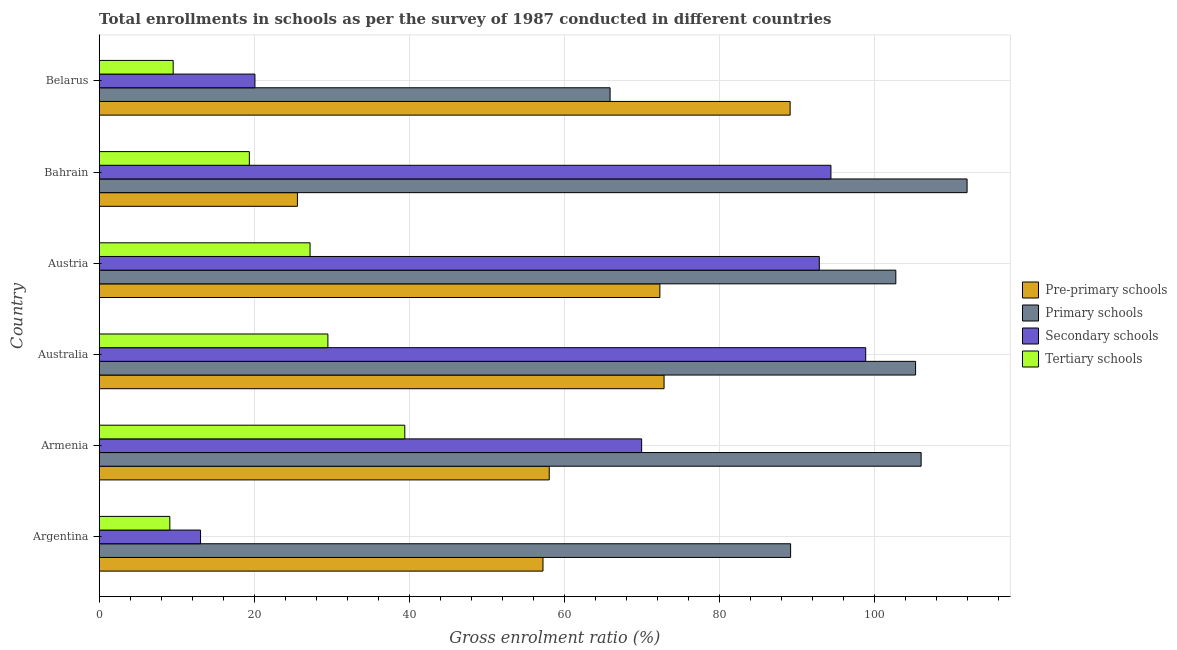How many different coloured bars are there?
Your answer should be compact. 4. Are the number of bars on each tick of the Y-axis equal?
Your response must be concise. Yes. How many bars are there on the 6th tick from the bottom?
Give a very brief answer. 4. What is the label of the 3rd group of bars from the top?
Ensure brevity in your answer.  Austria. In how many cases, is the number of bars for a given country not equal to the number of legend labels?
Provide a short and direct response. 0. What is the gross enrolment ratio in pre-primary schools in Australia?
Provide a succinct answer. 72.86. Across all countries, what is the maximum gross enrolment ratio in secondary schools?
Offer a very short reply. 98.86. Across all countries, what is the minimum gross enrolment ratio in secondary schools?
Ensure brevity in your answer.  13.07. In which country was the gross enrolment ratio in tertiary schools maximum?
Provide a succinct answer. Armenia. In which country was the gross enrolment ratio in tertiary schools minimum?
Offer a very short reply. Argentina. What is the total gross enrolment ratio in tertiary schools in the graph?
Your answer should be compact. 134.12. What is the difference between the gross enrolment ratio in secondary schools in Australia and that in Austria?
Give a very brief answer. 5.98. What is the difference between the gross enrolment ratio in tertiary schools in Australia and the gross enrolment ratio in primary schools in Armenia?
Your response must be concise. -76.52. What is the average gross enrolment ratio in pre-primary schools per country?
Your answer should be compact. 62.52. What is the difference between the gross enrolment ratio in primary schools and gross enrolment ratio in pre-primary schools in Australia?
Your response must be concise. 32.44. In how many countries, is the gross enrolment ratio in tertiary schools greater than 24 %?
Your answer should be compact. 3. What is the ratio of the gross enrolment ratio in pre-primary schools in Austria to that in Belarus?
Your answer should be very brief. 0.81. Is the gross enrolment ratio in primary schools in Armenia less than that in Austria?
Offer a terse response. No. What is the difference between the highest and the second highest gross enrolment ratio in tertiary schools?
Make the answer very short. 9.92. What is the difference between the highest and the lowest gross enrolment ratio in tertiary schools?
Your answer should be compact. 30.31. In how many countries, is the gross enrolment ratio in secondary schools greater than the average gross enrolment ratio in secondary schools taken over all countries?
Your response must be concise. 4. Is the sum of the gross enrolment ratio in secondary schools in Armenia and Australia greater than the maximum gross enrolment ratio in primary schools across all countries?
Offer a very short reply. Yes. Is it the case that in every country, the sum of the gross enrolment ratio in tertiary schools and gross enrolment ratio in secondary schools is greater than the sum of gross enrolment ratio in primary schools and gross enrolment ratio in pre-primary schools?
Give a very brief answer. No. What does the 2nd bar from the top in Argentina represents?
Offer a terse response. Secondary schools. What does the 2nd bar from the bottom in Australia represents?
Your answer should be compact. Primary schools. Is it the case that in every country, the sum of the gross enrolment ratio in pre-primary schools and gross enrolment ratio in primary schools is greater than the gross enrolment ratio in secondary schools?
Give a very brief answer. Yes. How many bars are there?
Your answer should be compact. 24. How many countries are there in the graph?
Your response must be concise. 6. What is the difference between two consecutive major ticks on the X-axis?
Make the answer very short. 20. Are the values on the major ticks of X-axis written in scientific E-notation?
Your answer should be compact. No. How are the legend labels stacked?
Your answer should be very brief. Vertical. What is the title of the graph?
Offer a very short reply. Total enrollments in schools as per the survey of 1987 conducted in different countries. Does "Secondary vocational education" appear as one of the legend labels in the graph?
Offer a terse response. No. What is the Gross enrolment ratio (%) of Pre-primary schools in Argentina?
Your answer should be very brief. 57.24. What is the Gross enrolment ratio (%) in Primary schools in Argentina?
Keep it short and to the point. 89.18. What is the Gross enrolment ratio (%) in Secondary schools in Argentina?
Give a very brief answer. 13.07. What is the Gross enrolment ratio (%) of Tertiary schools in Argentina?
Provide a succinct answer. 9.11. What is the Gross enrolment ratio (%) of Pre-primary schools in Armenia?
Offer a terse response. 58.04. What is the Gross enrolment ratio (%) in Primary schools in Armenia?
Your response must be concise. 106.01. What is the Gross enrolment ratio (%) in Secondary schools in Armenia?
Ensure brevity in your answer.  69.96. What is the Gross enrolment ratio (%) in Tertiary schools in Armenia?
Your answer should be very brief. 39.41. What is the Gross enrolment ratio (%) of Pre-primary schools in Australia?
Offer a very short reply. 72.86. What is the Gross enrolment ratio (%) in Primary schools in Australia?
Provide a succinct answer. 105.3. What is the Gross enrolment ratio (%) in Secondary schools in Australia?
Provide a short and direct response. 98.86. What is the Gross enrolment ratio (%) of Tertiary schools in Australia?
Provide a succinct answer. 29.5. What is the Gross enrolment ratio (%) of Pre-primary schools in Austria?
Offer a very short reply. 72.31. What is the Gross enrolment ratio (%) in Primary schools in Austria?
Your answer should be very brief. 102.75. What is the Gross enrolment ratio (%) in Secondary schools in Austria?
Give a very brief answer. 92.88. What is the Gross enrolment ratio (%) of Tertiary schools in Austria?
Your response must be concise. 27.19. What is the Gross enrolment ratio (%) of Pre-primary schools in Bahrain?
Offer a very short reply. 25.56. What is the Gross enrolment ratio (%) of Primary schools in Bahrain?
Your answer should be compact. 111.94. What is the Gross enrolment ratio (%) in Secondary schools in Bahrain?
Your answer should be compact. 94.38. What is the Gross enrolment ratio (%) of Tertiary schools in Bahrain?
Offer a terse response. 19.37. What is the Gross enrolment ratio (%) in Pre-primary schools in Belarus?
Make the answer very short. 89.12. What is the Gross enrolment ratio (%) in Primary schools in Belarus?
Offer a terse response. 65.89. What is the Gross enrolment ratio (%) in Secondary schools in Belarus?
Give a very brief answer. 20.09. What is the Gross enrolment ratio (%) of Tertiary schools in Belarus?
Ensure brevity in your answer.  9.54. Across all countries, what is the maximum Gross enrolment ratio (%) in Pre-primary schools?
Give a very brief answer. 89.12. Across all countries, what is the maximum Gross enrolment ratio (%) in Primary schools?
Your answer should be very brief. 111.94. Across all countries, what is the maximum Gross enrolment ratio (%) in Secondary schools?
Provide a short and direct response. 98.86. Across all countries, what is the maximum Gross enrolment ratio (%) of Tertiary schools?
Offer a very short reply. 39.41. Across all countries, what is the minimum Gross enrolment ratio (%) in Pre-primary schools?
Provide a short and direct response. 25.56. Across all countries, what is the minimum Gross enrolment ratio (%) of Primary schools?
Provide a short and direct response. 65.89. Across all countries, what is the minimum Gross enrolment ratio (%) of Secondary schools?
Keep it short and to the point. 13.07. Across all countries, what is the minimum Gross enrolment ratio (%) of Tertiary schools?
Your answer should be very brief. 9.11. What is the total Gross enrolment ratio (%) of Pre-primary schools in the graph?
Offer a very short reply. 375.13. What is the total Gross enrolment ratio (%) of Primary schools in the graph?
Your answer should be very brief. 581.07. What is the total Gross enrolment ratio (%) of Secondary schools in the graph?
Keep it short and to the point. 389.24. What is the total Gross enrolment ratio (%) of Tertiary schools in the graph?
Make the answer very short. 134.12. What is the difference between the Gross enrolment ratio (%) in Pre-primary schools in Argentina and that in Armenia?
Provide a succinct answer. -0.81. What is the difference between the Gross enrolment ratio (%) of Primary schools in Argentina and that in Armenia?
Ensure brevity in your answer.  -16.84. What is the difference between the Gross enrolment ratio (%) of Secondary schools in Argentina and that in Armenia?
Ensure brevity in your answer.  -56.89. What is the difference between the Gross enrolment ratio (%) of Tertiary schools in Argentina and that in Armenia?
Your answer should be very brief. -30.31. What is the difference between the Gross enrolment ratio (%) of Pre-primary schools in Argentina and that in Australia?
Provide a short and direct response. -15.62. What is the difference between the Gross enrolment ratio (%) in Primary schools in Argentina and that in Australia?
Provide a short and direct response. -16.12. What is the difference between the Gross enrolment ratio (%) of Secondary schools in Argentina and that in Australia?
Offer a very short reply. -85.79. What is the difference between the Gross enrolment ratio (%) of Tertiary schools in Argentina and that in Australia?
Provide a succinct answer. -20.39. What is the difference between the Gross enrolment ratio (%) of Pre-primary schools in Argentina and that in Austria?
Offer a very short reply. -15.08. What is the difference between the Gross enrolment ratio (%) in Primary schools in Argentina and that in Austria?
Offer a very short reply. -13.57. What is the difference between the Gross enrolment ratio (%) in Secondary schools in Argentina and that in Austria?
Offer a terse response. -79.81. What is the difference between the Gross enrolment ratio (%) of Tertiary schools in Argentina and that in Austria?
Your answer should be very brief. -18.09. What is the difference between the Gross enrolment ratio (%) in Pre-primary schools in Argentina and that in Bahrain?
Ensure brevity in your answer.  31.67. What is the difference between the Gross enrolment ratio (%) in Primary schools in Argentina and that in Bahrain?
Your answer should be very brief. -22.76. What is the difference between the Gross enrolment ratio (%) in Secondary schools in Argentina and that in Bahrain?
Provide a succinct answer. -81.31. What is the difference between the Gross enrolment ratio (%) of Tertiary schools in Argentina and that in Bahrain?
Offer a very short reply. -10.26. What is the difference between the Gross enrolment ratio (%) of Pre-primary schools in Argentina and that in Belarus?
Ensure brevity in your answer.  -31.88. What is the difference between the Gross enrolment ratio (%) in Primary schools in Argentina and that in Belarus?
Keep it short and to the point. 23.28. What is the difference between the Gross enrolment ratio (%) of Secondary schools in Argentina and that in Belarus?
Give a very brief answer. -7.02. What is the difference between the Gross enrolment ratio (%) of Tertiary schools in Argentina and that in Belarus?
Ensure brevity in your answer.  -0.43. What is the difference between the Gross enrolment ratio (%) of Pre-primary schools in Armenia and that in Australia?
Provide a short and direct response. -14.81. What is the difference between the Gross enrolment ratio (%) in Primary schools in Armenia and that in Australia?
Offer a terse response. 0.72. What is the difference between the Gross enrolment ratio (%) in Secondary schools in Armenia and that in Australia?
Give a very brief answer. -28.9. What is the difference between the Gross enrolment ratio (%) of Tertiary schools in Armenia and that in Australia?
Make the answer very short. 9.92. What is the difference between the Gross enrolment ratio (%) of Pre-primary schools in Armenia and that in Austria?
Ensure brevity in your answer.  -14.27. What is the difference between the Gross enrolment ratio (%) in Primary schools in Armenia and that in Austria?
Offer a very short reply. 3.26. What is the difference between the Gross enrolment ratio (%) of Secondary schools in Armenia and that in Austria?
Ensure brevity in your answer.  -22.92. What is the difference between the Gross enrolment ratio (%) of Tertiary schools in Armenia and that in Austria?
Give a very brief answer. 12.22. What is the difference between the Gross enrolment ratio (%) of Pre-primary schools in Armenia and that in Bahrain?
Give a very brief answer. 32.48. What is the difference between the Gross enrolment ratio (%) in Primary schools in Armenia and that in Bahrain?
Provide a succinct answer. -5.93. What is the difference between the Gross enrolment ratio (%) of Secondary schools in Armenia and that in Bahrain?
Your answer should be compact. -24.42. What is the difference between the Gross enrolment ratio (%) of Tertiary schools in Armenia and that in Bahrain?
Ensure brevity in your answer.  20.05. What is the difference between the Gross enrolment ratio (%) of Pre-primary schools in Armenia and that in Belarus?
Keep it short and to the point. -31.07. What is the difference between the Gross enrolment ratio (%) of Primary schools in Armenia and that in Belarus?
Provide a short and direct response. 40.12. What is the difference between the Gross enrolment ratio (%) of Secondary schools in Armenia and that in Belarus?
Make the answer very short. 49.88. What is the difference between the Gross enrolment ratio (%) of Tertiary schools in Armenia and that in Belarus?
Give a very brief answer. 29.87. What is the difference between the Gross enrolment ratio (%) of Pre-primary schools in Australia and that in Austria?
Ensure brevity in your answer.  0.54. What is the difference between the Gross enrolment ratio (%) in Primary schools in Australia and that in Austria?
Ensure brevity in your answer.  2.55. What is the difference between the Gross enrolment ratio (%) of Secondary schools in Australia and that in Austria?
Keep it short and to the point. 5.98. What is the difference between the Gross enrolment ratio (%) of Tertiary schools in Australia and that in Austria?
Make the answer very short. 2.3. What is the difference between the Gross enrolment ratio (%) of Pre-primary schools in Australia and that in Bahrain?
Your response must be concise. 47.29. What is the difference between the Gross enrolment ratio (%) in Primary schools in Australia and that in Bahrain?
Provide a succinct answer. -6.64. What is the difference between the Gross enrolment ratio (%) of Secondary schools in Australia and that in Bahrain?
Ensure brevity in your answer.  4.48. What is the difference between the Gross enrolment ratio (%) in Tertiary schools in Australia and that in Bahrain?
Ensure brevity in your answer.  10.13. What is the difference between the Gross enrolment ratio (%) of Pre-primary schools in Australia and that in Belarus?
Make the answer very short. -16.26. What is the difference between the Gross enrolment ratio (%) of Primary schools in Australia and that in Belarus?
Offer a terse response. 39.4. What is the difference between the Gross enrolment ratio (%) in Secondary schools in Australia and that in Belarus?
Make the answer very short. 78.78. What is the difference between the Gross enrolment ratio (%) in Tertiary schools in Australia and that in Belarus?
Your answer should be very brief. 19.95. What is the difference between the Gross enrolment ratio (%) of Pre-primary schools in Austria and that in Bahrain?
Give a very brief answer. 46.75. What is the difference between the Gross enrolment ratio (%) in Primary schools in Austria and that in Bahrain?
Give a very brief answer. -9.19. What is the difference between the Gross enrolment ratio (%) of Secondary schools in Austria and that in Bahrain?
Keep it short and to the point. -1.5. What is the difference between the Gross enrolment ratio (%) in Tertiary schools in Austria and that in Bahrain?
Your answer should be compact. 7.83. What is the difference between the Gross enrolment ratio (%) of Pre-primary schools in Austria and that in Belarus?
Give a very brief answer. -16.8. What is the difference between the Gross enrolment ratio (%) of Primary schools in Austria and that in Belarus?
Ensure brevity in your answer.  36.86. What is the difference between the Gross enrolment ratio (%) of Secondary schools in Austria and that in Belarus?
Ensure brevity in your answer.  72.79. What is the difference between the Gross enrolment ratio (%) of Tertiary schools in Austria and that in Belarus?
Your answer should be very brief. 17.65. What is the difference between the Gross enrolment ratio (%) of Pre-primary schools in Bahrain and that in Belarus?
Provide a succinct answer. -63.55. What is the difference between the Gross enrolment ratio (%) in Primary schools in Bahrain and that in Belarus?
Your answer should be compact. 46.05. What is the difference between the Gross enrolment ratio (%) in Secondary schools in Bahrain and that in Belarus?
Keep it short and to the point. 74.29. What is the difference between the Gross enrolment ratio (%) of Tertiary schools in Bahrain and that in Belarus?
Your answer should be compact. 9.83. What is the difference between the Gross enrolment ratio (%) of Pre-primary schools in Argentina and the Gross enrolment ratio (%) of Primary schools in Armenia?
Make the answer very short. -48.78. What is the difference between the Gross enrolment ratio (%) in Pre-primary schools in Argentina and the Gross enrolment ratio (%) in Secondary schools in Armenia?
Ensure brevity in your answer.  -12.73. What is the difference between the Gross enrolment ratio (%) in Pre-primary schools in Argentina and the Gross enrolment ratio (%) in Tertiary schools in Armenia?
Offer a very short reply. 17.82. What is the difference between the Gross enrolment ratio (%) in Primary schools in Argentina and the Gross enrolment ratio (%) in Secondary schools in Armenia?
Offer a very short reply. 19.22. What is the difference between the Gross enrolment ratio (%) of Primary schools in Argentina and the Gross enrolment ratio (%) of Tertiary schools in Armenia?
Make the answer very short. 49.76. What is the difference between the Gross enrolment ratio (%) of Secondary schools in Argentina and the Gross enrolment ratio (%) of Tertiary schools in Armenia?
Your answer should be very brief. -26.35. What is the difference between the Gross enrolment ratio (%) of Pre-primary schools in Argentina and the Gross enrolment ratio (%) of Primary schools in Australia?
Give a very brief answer. -48.06. What is the difference between the Gross enrolment ratio (%) in Pre-primary schools in Argentina and the Gross enrolment ratio (%) in Secondary schools in Australia?
Your response must be concise. -41.63. What is the difference between the Gross enrolment ratio (%) of Pre-primary schools in Argentina and the Gross enrolment ratio (%) of Tertiary schools in Australia?
Your response must be concise. 27.74. What is the difference between the Gross enrolment ratio (%) in Primary schools in Argentina and the Gross enrolment ratio (%) in Secondary schools in Australia?
Ensure brevity in your answer.  -9.68. What is the difference between the Gross enrolment ratio (%) in Primary schools in Argentina and the Gross enrolment ratio (%) in Tertiary schools in Australia?
Offer a terse response. 59.68. What is the difference between the Gross enrolment ratio (%) of Secondary schools in Argentina and the Gross enrolment ratio (%) of Tertiary schools in Australia?
Your answer should be very brief. -16.43. What is the difference between the Gross enrolment ratio (%) in Pre-primary schools in Argentina and the Gross enrolment ratio (%) in Primary schools in Austria?
Your answer should be very brief. -45.51. What is the difference between the Gross enrolment ratio (%) in Pre-primary schools in Argentina and the Gross enrolment ratio (%) in Secondary schools in Austria?
Make the answer very short. -35.64. What is the difference between the Gross enrolment ratio (%) in Pre-primary schools in Argentina and the Gross enrolment ratio (%) in Tertiary schools in Austria?
Keep it short and to the point. 30.04. What is the difference between the Gross enrolment ratio (%) in Primary schools in Argentina and the Gross enrolment ratio (%) in Secondary schools in Austria?
Give a very brief answer. -3.7. What is the difference between the Gross enrolment ratio (%) in Primary schools in Argentina and the Gross enrolment ratio (%) in Tertiary schools in Austria?
Your answer should be very brief. 61.98. What is the difference between the Gross enrolment ratio (%) in Secondary schools in Argentina and the Gross enrolment ratio (%) in Tertiary schools in Austria?
Keep it short and to the point. -14.13. What is the difference between the Gross enrolment ratio (%) of Pre-primary schools in Argentina and the Gross enrolment ratio (%) of Primary schools in Bahrain?
Offer a very short reply. -54.7. What is the difference between the Gross enrolment ratio (%) in Pre-primary schools in Argentina and the Gross enrolment ratio (%) in Secondary schools in Bahrain?
Give a very brief answer. -37.14. What is the difference between the Gross enrolment ratio (%) of Pre-primary schools in Argentina and the Gross enrolment ratio (%) of Tertiary schools in Bahrain?
Provide a short and direct response. 37.87. What is the difference between the Gross enrolment ratio (%) of Primary schools in Argentina and the Gross enrolment ratio (%) of Tertiary schools in Bahrain?
Make the answer very short. 69.81. What is the difference between the Gross enrolment ratio (%) in Secondary schools in Argentina and the Gross enrolment ratio (%) in Tertiary schools in Bahrain?
Your response must be concise. -6.3. What is the difference between the Gross enrolment ratio (%) in Pre-primary schools in Argentina and the Gross enrolment ratio (%) in Primary schools in Belarus?
Give a very brief answer. -8.66. What is the difference between the Gross enrolment ratio (%) of Pre-primary schools in Argentina and the Gross enrolment ratio (%) of Secondary schools in Belarus?
Make the answer very short. 37.15. What is the difference between the Gross enrolment ratio (%) of Pre-primary schools in Argentina and the Gross enrolment ratio (%) of Tertiary schools in Belarus?
Keep it short and to the point. 47.7. What is the difference between the Gross enrolment ratio (%) in Primary schools in Argentina and the Gross enrolment ratio (%) in Secondary schools in Belarus?
Your answer should be compact. 69.09. What is the difference between the Gross enrolment ratio (%) of Primary schools in Argentina and the Gross enrolment ratio (%) of Tertiary schools in Belarus?
Give a very brief answer. 79.64. What is the difference between the Gross enrolment ratio (%) of Secondary schools in Argentina and the Gross enrolment ratio (%) of Tertiary schools in Belarus?
Offer a terse response. 3.53. What is the difference between the Gross enrolment ratio (%) in Pre-primary schools in Armenia and the Gross enrolment ratio (%) in Primary schools in Australia?
Provide a succinct answer. -47.25. What is the difference between the Gross enrolment ratio (%) of Pre-primary schools in Armenia and the Gross enrolment ratio (%) of Secondary schools in Australia?
Offer a very short reply. -40.82. What is the difference between the Gross enrolment ratio (%) in Pre-primary schools in Armenia and the Gross enrolment ratio (%) in Tertiary schools in Australia?
Give a very brief answer. 28.55. What is the difference between the Gross enrolment ratio (%) of Primary schools in Armenia and the Gross enrolment ratio (%) of Secondary schools in Australia?
Give a very brief answer. 7.15. What is the difference between the Gross enrolment ratio (%) of Primary schools in Armenia and the Gross enrolment ratio (%) of Tertiary schools in Australia?
Offer a very short reply. 76.52. What is the difference between the Gross enrolment ratio (%) of Secondary schools in Armenia and the Gross enrolment ratio (%) of Tertiary schools in Australia?
Make the answer very short. 40.47. What is the difference between the Gross enrolment ratio (%) in Pre-primary schools in Armenia and the Gross enrolment ratio (%) in Primary schools in Austria?
Provide a short and direct response. -44.71. What is the difference between the Gross enrolment ratio (%) in Pre-primary schools in Armenia and the Gross enrolment ratio (%) in Secondary schools in Austria?
Ensure brevity in your answer.  -34.84. What is the difference between the Gross enrolment ratio (%) in Pre-primary schools in Armenia and the Gross enrolment ratio (%) in Tertiary schools in Austria?
Provide a short and direct response. 30.85. What is the difference between the Gross enrolment ratio (%) in Primary schools in Armenia and the Gross enrolment ratio (%) in Secondary schools in Austria?
Provide a short and direct response. 13.13. What is the difference between the Gross enrolment ratio (%) in Primary schools in Armenia and the Gross enrolment ratio (%) in Tertiary schools in Austria?
Offer a terse response. 78.82. What is the difference between the Gross enrolment ratio (%) of Secondary schools in Armenia and the Gross enrolment ratio (%) of Tertiary schools in Austria?
Ensure brevity in your answer.  42.77. What is the difference between the Gross enrolment ratio (%) of Pre-primary schools in Armenia and the Gross enrolment ratio (%) of Primary schools in Bahrain?
Provide a short and direct response. -53.9. What is the difference between the Gross enrolment ratio (%) in Pre-primary schools in Armenia and the Gross enrolment ratio (%) in Secondary schools in Bahrain?
Offer a very short reply. -36.33. What is the difference between the Gross enrolment ratio (%) of Pre-primary schools in Armenia and the Gross enrolment ratio (%) of Tertiary schools in Bahrain?
Your response must be concise. 38.68. What is the difference between the Gross enrolment ratio (%) in Primary schools in Armenia and the Gross enrolment ratio (%) in Secondary schools in Bahrain?
Make the answer very short. 11.64. What is the difference between the Gross enrolment ratio (%) of Primary schools in Armenia and the Gross enrolment ratio (%) of Tertiary schools in Bahrain?
Keep it short and to the point. 86.65. What is the difference between the Gross enrolment ratio (%) of Secondary schools in Armenia and the Gross enrolment ratio (%) of Tertiary schools in Bahrain?
Provide a succinct answer. 50.6. What is the difference between the Gross enrolment ratio (%) of Pre-primary schools in Armenia and the Gross enrolment ratio (%) of Primary schools in Belarus?
Ensure brevity in your answer.  -7.85. What is the difference between the Gross enrolment ratio (%) of Pre-primary schools in Armenia and the Gross enrolment ratio (%) of Secondary schools in Belarus?
Offer a very short reply. 37.96. What is the difference between the Gross enrolment ratio (%) of Pre-primary schools in Armenia and the Gross enrolment ratio (%) of Tertiary schools in Belarus?
Make the answer very short. 48.5. What is the difference between the Gross enrolment ratio (%) in Primary schools in Armenia and the Gross enrolment ratio (%) in Secondary schools in Belarus?
Offer a very short reply. 85.93. What is the difference between the Gross enrolment ratio (%) of Primary schools in Armenia and the Gross enrolment ratio (%) of Tertiary schools in Belarus?
Your answer should be very brief. 96.47. What is the difference between the Gross enrolment ratio (%) of Secondary schools in Armenia and the Gross enrolment ratio (%) of Tertiary schools in Belarus?
Your answer should be compact. 60.42. What is the difference between the Gross enrolment ratio (%) in Pre-primary schools in Australia and the Gross enrolment ratio (%) in Primary schools in Austria?
Provide a short and direct response. -29.89. What is the difference between the Gross enrolment ratio (%) in Pre-primary schools in Australia and the Gross enrolment ratio (%) in Secondary schools in Austria?
Make the answer very short. -20.02. What is the difference between the Gross enrolment ratio (%) in Pre-primary schools in Australia and the Gross enrolment ratio (%) in Tertiary schools in Austria?
Provide a short and direct response. 45.66. What is the difference between the Gross enrolment ratio (%) in Primary schools in Australia and the Gross enrolment ratio (%) in Secondary schools in Austria?
Make the answer very short. 12.42. What is the difference between the Gross enrolment ratio (%) of Primary schools in Australia and the Gross enrolment ratio (%) of Tertiary schools in Austria?
Keep it short and to the point. 78.1. What is the difference between the Gross enrolment ratio (%) in Secondary schools in Australia and the Gross enrolment ratio (%) in Tertiary schools in Austria?
Ensure brevity in your answer.  71.67. What is the difference between the Gross enrolment ratio (%) of Pre-primary schools in Australia and the Gross enrolment ratio (%) of Primary schools in Bahrain?
Make the answer very short. -39.08. What is the difference between the Gross enrolment ratio (%) in Pre-primary schools in Australia and the Gross enrolment ratio (%) in Secondary schools in Bahrain?
Offer a terse response. -21.52. What is the difference between the Gross enrolment ratio (%) in Pre-primary schools in Australia and the Gross enrolment ratio (%) in Tertiary schools in Bahrain?
Your answer should be very brief. 53.49. What is the difference between the Gross enrolment ratio (%) of Primary schools in Australia and the Gross enrolment ratio (%) of Secondary schools in Bahrain?
Your answer should be compact. 10.92. What is the difference between the Gross enrolment ratio (%) in Primary schools in Australia and the Gross enrolment ratio (%) in Tertiary schools in Bahrain?
Your answer should be compact. 85.93. What is the difference between the Gross enrolment ratio (%) of Secondary schools in Australia and the Gross enrolment ratio (%) of Tertiary schools in Bahrain?
Your answer should be very brief. 79.5. What is the difference between the Gross enrolment ratio (%) in Pre-primary schools in Australia and the Gross enrolment ratio (%) in Primary schools in Belarus?
Give a very brief answer. 6.96. What is the difference between the Gross enrolment ratio (%) in Pre-primary schools in Australia and the Gross enrolment ratio (%) in Secondary schools in Belarus?
Ensure brevity in your answer.  52.77. What is the difference between the Gross enrolment ratio (%) of Pre-primary schools in Australia and the Gross enrolment ratio (%) of Tertiary schools in Belarus?
Offer a terse response. 63.32. What is the difference between the Gross enrolment ratio (%) of Primary schools in Australia and the Gross enrolment ratio (%) of Secondary schools in Belarus?
Ensure brevity in your answer.  85.21. What is the difference between the Gross enrolment ratio (%) in Primary schools in Australia and the Gross enrolment ratio (%) in Tertiary schools in Belarus?
Provide a succinct answer. 95.76. What is the difference between the Gross enrolment ratio (%) in Secondary schools in Australia and the Gross enrolment ratio (%) in Tertiary schools in Belarus?
Offer a terse response. 89.32. What is the difference between the Gross enrolment ratio (%) of Pre-primary schools in Austria and the Gross enrolment ratio (%) of Primary schools in Bahrain?
Your response must be concise. -39.62. What is the difference between the Gross enrolment ratio (%) in Pre-primary schools in Austria and the Gross enrolment ratio (%) in Secondary schools in Bahrain?
Your response must be concise. -22.06. What is the difference between the Gross enrolment ratio (%) of Pre-primary schools in Austria and the Gross enrolment ratio (%) of Tertiary schools in Bahrain?
Offer a terse response. 52.95. What is the difference between the Gross enrolment ratio (%) in Primary schools in Austria and the Gross enrolment ratio (%) in Secondary schools in Bahrain?
Your answer should be compact. 8.37. What is the difference between the Gross enrolment ratio (%) in Primary schools in Austria and the Gross enrolment ratio (%) in Tertiary schools in Bahrain?
Keep it short and to the point. 83.38. What is the difference between the Gross enrolment ratio (%) of Secondary schools in Austria and the Gross enrolment ratio (%) of Tertiary schools in Bahrain?
Offer a very short reply. 73.51. What is the difference between the Gross enrolment ratio (%) of Pre-primary schools in Austria and the Gross enrolment ratio (%) of Primary schools in Belarus?
Ensure brevity in your answer.  6.42. What is the difference between the Gross enrolment ratio (%) of Pre-primary schools in Austria and the Gross enrolment ratio (%) of Secondary schools in Belarus?
Ensure brevity in your answer.  52.23. What is the difference between the Gross enrolment ratio (%) of Pre-primary schools in Austria and the Gross enrolment ratio (%) of Tertiary schools in Belarus?
Your answer should be very brief. 62.77. What is the difference between the Gross enrolment ratio (%) of Primary schools in Austria and the Gross enrolment ratio (%) of Secondary schools in Belarus?
Make the answer very short. 82.66. What is the difference between the Gross enrolment ratio (%) of Primary schools in Austria and the Gross enrolment ratio (%) of Tertiary schools in Belarus?
Offer a terse response. 93.21. What is the difference between the Gross enrolment ratio (%) of Secondary schools in Austria and the Gross enrolment ratio (%) of Tertiary schools in Belarus?
Keep it short and to the point. 83.34. What is the difference between the Gross enrolment ratio (%) of Pre-primary schools in Bahrain and the Gross enrolment ratio (%) of Primary schools in Belarus?
Offer a very short reply. -40.33. What is the difference between the Gross enrolment ratio (%) in Pre-primary schools in Bahrain and the Gross enrolment ratio (%) in Secondary schools in Belarus?
Your response must be concise. 5.48. What is the difference between the Gross enrolment ratio (%) of Pre-primary schools in Bahrain and the Gross enrolment ratio (%) of Tertiary schools in Belarus?
Your response must be concise. 16.02. What is the difference between the Gross enrolment ratio (%) of Primary schools in Bahrain and the Gross enrolment ratio (%) of Secondary schools in Belarus?
Give a very brief answer. 91.85. What is the difference between the Gross enrolment ratio (%) of Primary schools in Bahrain and the Gross enrolment ratio (%) of Tertiary schools in Belarus?
Give a very brief answer. 102.4. What is the difference between the Gross enrolment ratio (%) in Secondary schools in Bahrain and the Gross enrolment ratio (%) in Tertiary schools in Belarus?
Ensure brevity in your answer.  84.84. What is the average Gross enrolment ratio (%) in Pre-primary schools per country?
Provide a short and direct response. 62.52. What is the average Gross enrolment ratio (%) of Primary schools per country?
Give a very brief answer. 96.84. What is the average Gross enrolment ratio (%) in Secondary schools per country?
Provide a succinct answer. 64.87. What is the average Gross enrolment ratio (%) of Tertiary schools per country?
Give a very brief answer. 22.35. What is the difference between the Gross enrolment ratio (%) of Pre-primary schools and Gross enrolment ratio (%) of Primary schools in Argentina?
Ensure brevity in your answer.  -31.94. What is the difference between the Gross enrolment ratio (%) in Pre-primary schools and Gross enrolment ratio (%) in Secondary schools in Argentina?
Keep it short and to the point. 44.17. What is the difference between the Gross enrolment ratio (%) of Pre-primary schools and Gross enrolment ratio (%) of Tertiary schools in Argentina?
Your answer should be very brief. 48.13. What is the difference between the Gross enrolment ratio (%) of Primary schools and Gross enrolment ratio (%) of Secondary schools in Argentina?
Make the answer very short. 76.11. What is the difference between the Gross enrolment ratio (%) in Primary schools and Gross enrolment ratio (%) in Tertiary schools in Argentina?
Your answer should be very brief. 80.07. What is the difference between the Gross enrolment ratio (%) of Secondary schools and Gross enrolment ratio (%) of Tertiary schools in Argentina?
Give a very brief answer. 3.96. What is the difference between the Gross enrolment ratio (%) of Pre-primary schools and Gross enrolment ratio (%) of Primary schools in Armenia?
Provide a short and direct response. -47.97. What is the difference between the Gross enrolment ratio (%) in Pre-primary schools and Gross enrolment ratio (%) in Secondary schools in Armenia?
Make the answer very short. -11.92. What is the difference between the Gross enrolment ratio (%) of Pre-primary schools and Gross enrolment ratio (%) of Tertiary schools in Armenia?
Your answer should be very brief. 18.63. What is the difference between the Gross enrolment ratio (%) in Primary schools and Gross enrolment ratio (%) in Secondary schools in Armenia?
Provide a short and direct response. 36.05. What is the difference between the Gross enrolment ratio (%) in Primary schools and Gross enrolment ratio (%) in Tertiary schools in Armenia?
Provide a succinct answer. 66.6. What is the difference between the Gross enrolment ratio (%) of Secondary schools and Gross enrolment ratio (%) of Tertiary schools in Armenia?
Give a very brief answer. 30.55. What is the difference between the Gross enrolment ratio (%) in Pre-primary schools and Gross enrolment ratio (%) in Primary schools in Australia?
Your response must be concise. -32.44. What is the difference between the Gross enrolment ratio (%) of Pre-primary schools and Gross enrolment ratio (%) of Secondary schools in Australia?
Keep it short and to the point. -26.01. What is the difference between the Gross enrolment ratio (%) in Pre-primary schools and Gross enrolment ratio (%) in Tertiary schools in Australia?
Offer a terse response. 43.36. What is the difference between the Gross enrolment ratio (%) of Primary schools and Gross enrolment ratio (%) of Secondary schools in Australia?
Make the answer very short. 6.44. What is the difference between the Gross enrolment ratio (%) of Primary schools and Gross enrolment ratio (%) of Tertiary schools in Australia?
Ensure brevity in your answer.  75.8. What is the difference between the Gross enrolment ratio (%) of Secondary schools and Gross enrolment ratio (%) of Tertiary schools in Australia?
Offer a very short reply. 69.37. What is the difference between the Gross enrolment ratio (%) in Pre-primary schools and Gross enrolment ratio (%) in Primary schools in Austria?
Your answer should be very brief. -30.43. What is the difference between the Gross enrolment ratio (%) of Pre-primary schools and Gross enrolment ratio (%) of Secondary schools in Austria?
Your answer should be very brief. -20.57. What is the difference between the Gross enrolment ratio (%) in Pre-primary schools and Gross enrolment ratio (%) in Tertiary schools in Austria?
Provide a short and direct response. 45.12. What is the difference between the Gross enrolment ratio (%) in Primary schools and Gross enrolment ratio (%) in Secondary schools in Austria?
Give a very brief answer. 9.87. What is the difference between the Gross enrolment ratio (%) of Primary schools and Gross enrolment ratio (%) of Tertiary schools in Austria?
Ensure brevity in your answer.  75.55. What is the difference between the Gross enrolment ratio (%) in Secondary schools and Gross enrolment ratio (%) in Tertiary schools in Austria?
Offer a terse response. 65.68. What is the difference between the Gross enrolment ratio (%) in Pre-primary schools and Gross enrolment ratio (%) in Primary schools in Bahrain?
Offer a very short reply. -86.37. What is the difference between the Gross enrolment ratio (%) of Pre-primary schools and Gross enrolment ratio (%) of Secondary schools in Bahrain?
Provide a short and direct response. -68.81. What is the difference between the Gross enrolment ratio (%) of Pre-primary schools and Gross enrolment ratio (%) of Tertiary schools in Bahrain?
Offer a terse response. 6.2. What is the difference between the Gross enrolment ratio (%) of Primary schools and Gross enrolment ratio (%) of Secondary schools in Bahrain?
Your answer should be very brief. 17.56. What is the difference between the Gross enrolment ratio (%) of Primary schools and Gross enrolment ratio (%) of Tertiary schools in Bahrain?
Provide a succinct answer. 92.57. What is the difference between the Gross enrolment ratio (%) of Secondary schools and Gross enrolment ratio (%) of Tertiary schools in Bahrain?
Your answer should be very brief. 75.01. What is the difference between the Gross enrolment ratio (%) of Pre-primary schools and Gross enrolment ratio (%) of Primary schools in Belarus?
Keep it short and to the point. 23.22. What is the difference between the Gross enrolment ratio (%) of Pre-primary schools and Gross enrolment ratio (%) of Secondary schools in Belarus?
Give a very brief answer. 69.03. What is the difference between the Gross enrolment ratio (%) in Pre-primary schools and Gross enrolment ratio (%) in Tertiary schools in Belarus?
Your response must be concise. 79.58. What is the difference between the Gross enrolment ratio (%) of Primary schools and Gross enrolment ratio (%) of Secondary schools in Belarus?
Your answer should be compact. 45.81. What is the difference between the Gross enrolment ratio (%) of Primary schools and Gross enrolment ratio (%) of Tertiary schools in Belarus?
Your answer should be very brief. 56.35. What is the difference between the Gross enrolment ratio (%) of Secondary schools and Gross enrolment ratio (%) of Tertiary schools in Belarus?
Make the answer very short. 10.55. What is the ratio of the Gross enrolment ratio (%) of Pre-primary schools in Argentina to that in Armenia?
Ensure brevity in your answer.  0.99. What is the ratio of the Gross enrolment ratio (%) in Primary schools in Argentina to that in Armenia?
Keep it short and to the point. 0.84. What is the ratio of the Gross enrolment ratio (%) in Secondary schools in Argentina to that in Armenia?
Offer a terse response. 0.19. What is the ratio of the Gross enrolment ratio (%) of Tertiary schools in Argentina to that in Armenia?
Your response must be concise. 0.23. What is the ratio of the Gross enrolment ratio (%) of Pre-primary schools in Argentina to that in Australia?
Your response must be concise. 0.79. What is the ratio of the Gross enrolment ratio (%) of Primary schools in Argentina to that in Australia?
Provide a succinct answer. 0.85. What is the ratio of the Gross enrolment ratio (%) of Secondary schools in Argentina to that in Australia?
Give a very brief answer. 0.13. What is the ratio of the Gross enrolment ratio (%) of Tertiary schools in Argentina to that in Australia?
Keep it short and to the point. 0.31. What is the ratio of the Gross enrolment ratio (%) of Pre-primary schools in Argentina to that in Austria?
Keep it short and to the point. 0.79. What is the ratio of the Gross enrolment ratio (%) of Primary schools in Argentina to that in Austria?
Give a very brief answer. 0.87. What is the ratio of the Gross enrolment ratio (%) of Secondary schools in Argentina to that in Austria?
Provide a succinct answer. 0.14. What is the ratio of the Gross enrolment ratio (%) of Tertiary schools in Argentina to that in Austria?
Provide a short and direct response. 0.33. What is the ratio of the Gross enrolment ratio (%) in Pre-primary schools in Argentina to that in Bahrain?
Offer a terse response. 2.24. What is the ratio of the Gross enrolment ratio (%) of Primary schools in Argentina to that in Bahrain?
Your answer should be compact. 0.8. What is the ratio of the Gross enrolment ratio (%) in Secondary schools in Argentina to that in Bahrain?
Offer a very short reply. 0.14. What is the ratio of the Gross enrolment ratio (%) of Tertiary schools in Argentina to that in Bahrain?
Your answer should be compact. 0.47. What is the ratio of the Gross enrolment ratio (%) of Pre-primary schools in Argentina to that in Belarus?
Give a very brief answer. 0.64. What is the ratio of the Gross enrolment ratio (%) of Primary schools in Argentina to that in Belarus?
Give a very brief answer. 1.35. What is the ratio of the Gross enrolment ratio (%) of Secondary schools in Argentina to that in Belarus?
Make the answer very short. 0.65. What is the ratio of the Gross enrolment ratio (%) of Tertiary schools in Argentina to that in Belarus?
Your answer should be compact. 0.95. What is the ratio of the Gross enrolment ratio (%) of Pre-primary schools in Armenia to that in Australia?
Provide a succinct answer. 0.8. What is the ratio of the Gross enrolment ratio (%) of Primary schools in Armenia to that in Australia?
Make the answer very short. 1.01. What is the ratio of the Gross enrolment ratio (%) of Secondary schools in Armenia to that in Australia?
Provide a succinct answer. 0.71. What is the ratio of the Gross enrolment ratio (%) of Tertiary schools in Armenia to that in Australia?
Your answer should be compact. 1.34. What is the ratio of the Gross enrolment ratio (%) of Pre-primary schools in Armenia to that in Austria?
Your response must be concise. 0.8. What is the ratio of the Gross enrolment ratio (%) in Primary schools in Armenia to that in Austria?
Provide a short and direct response. 1.03. What is the ratio of the Gross enrolment ratio (%) in Secondary schools in Armenia to that in Austria?
Offer a very short reply. 0.75. What is the ratio of the Gross enrolment ratio (%) of Tertiary schools in Armenia to that in Austria?
Offer a very short reply. 1.45. What is the ratio of the Gross enrolment ratio (%) of Pre-primary schools in Armenia to that in Bahrain?
Your answer should be compact. 2.27. What is the ratio of the Gross enrolment ratio (%) of Primary schools in Armenia to that in Bahrain?
Give a very brief answer. 0.95. What is the ratio of the Gross enrolment ratio (%) of Secondary schools in Armenia to that in Bahrain?
Your answer should be very brief. 0.74. What is the ratio of the Gross enrolment ratio (%) of Tertiary schools in Armenia to that in Bahrain?
Offer a terse response. 2.04. What is the ratio of the Gross enrolment ratio (%) of Pre-primary schools in Armenia to that in Belarus?
Give a very brief answer. 0.65. What is the ratio of the Gross enrolment ratio (%) in Primary schools in Armenia to that in Belarus?
Your answer should be compact. 1.61. What is the ratio of the Gross enrolment ratio (%) of Secondary schools in Armenia to that in Belarus?
Make the answer very short. 3.48. What is the ratio of the Gross enrolment ratio (%) of Tertiary schools in Armenia to that in Belarus?
Keep it short and to the point. 4.13. What is the ratio of the Gross enrolment ratio (%) in Pre-primary schools in Australia to that in Austria?
Provide a short and direct response. 1.01. What is the ratio of the Gross enrolment ratio (%) of Primary schools in Australia to that in Austria?
Your response must be concise. 1.02. What is the ratio of the Gross enrolment ratio (%) of Secondary schools in Australia to that in Austria?
Provide a short and direct response. 1.06. What is the ratio of the Gross enrolment ratio (%) of Tertiary schools in Australia to that in Austria?
Provide a short and direct response. 1.08. What is the ratio of the Gross enrolment ratio (%) of Pre-primary schools in Australia to that in Bahrain?
Offer a very short reply. 2.85. What is the ratio of the Gross enrolment ratio (%) of Primary schools in Australia to that in Bahrain?
Give a very brief answer. 0.94. What is the ratio of the Gross enrolment ratio (%) of Secondary schools in Australia to that in Bahrain?
Your answer should be compact. 1.05. What is the ratio of the Gross enrolment ratio (%) in Tertiary schools in Australia to that in Bahrain?
Provide a succinct answer. 1.52. What is the ratio of the Gross enrolment ratio (%) in Pre-primary schools in Australia to that in Belarus?
Make the answer very short. 0.82. What is the ratio of the Gross enrolment ratio (%) in Primary schools in Australia to that in Belarus?
Offer a very short reply. 1.6. What is the ratio of the Gross enrolment ratio (%) in Secondary schools in Australia to that in Belarus?
Offer a terse response. 4.92. What is the ratio of the Gross enrolment ratio (%) of Tertiary schools in Australia to that in Belarus?
Your response must be concise. 3.09. What is the ratio of the Gross enrolment ratio (%) of Pre-primary schools in Austria to that in Bahrain?
Ensure brevity in your answer.  2.83. What is the ratio of the Gross enrolment ratio (%) of Primary schools in Austria to that in Bahrain?
Offer a terse response. 0.92. What is the ratio of the Gross enrolment ratio (%) in Secondary schools in Austria to that in Bahrain?
Keep it short and to the point. 0.98. What is the ratio of the Gross enrolment ratio (%) in Tertiary schools in Austria to that in Bahrain?
Your answer should be very brief. 1.4. What is the ratio of the Gross enrolment ratio (%) in Pre-primary schools in Austria to that in Belarus?
Provide a succinct answer. 0.81. What is the ratio of the Gross enrolment ratio (%) of Primary schools in Austria to that in Belarus?
Give a very brief answer. 1.56. What is the ratio of the Gross enrolment ratio (%) in Secondary schools in Austria to that in Belarus?
Your answer should be compact. 4.62. What is the ratio of the Gross enrolment ratio (%) in Tertiary schools in Austria to that in Belarus?
Make the answer very short. 2.85. What is the ratio of the Gross enrolment ratio (%) in Pre-primary schools in Bahrain to that in Belarus?
Keep it short and to the point. 0.29. What is the ratio of the Gross enrolment ratio (%) in Primary schools in Bahrain to that in Belarus?
Provide a short and direct response. 1.7. What is the ratio of the Gross enrolment ratio (%) of Secondary schools in Bahrain to that in Belarus?
Your response must be concise. 4.7. What is the ratio of the Gross enrolment ratio (%) of Tertiary schools in Bahrain to that in Belarus?
Your answer should be compact. 2.03. What is the difference between the highest and the second highest Gross enrolment ratio (%) of Pre-primary schools?
Offer a terse response. 16.26. What is the difference between the highest and the second highest Gross enrolment ratio (%) of Primary schools?
Make the answer very short. 5.93. What is the difference between the highest and the second highest Gross enrolment ratio (%) of Secondary schools?
Your response must be concise. 4.48. What is the difference between the highest and the second highest Gross enrolment ratio (%) of Tertiary schools?
Make the answer very short. 9.92. What is the difference between the highest and the lowest Gross enrolment ratio (%) in Pre-primary schools?
Your answer should be compact. 63.55. What is the difference between the highest and the lowest Gross enrolment ratio (%) of Primary schools?
Provide a succinct answer. 46.05. What is the difference between the highest and the lowest Gross enrolment ratio (%) in Secondary schools?
Your answer should be compact. 85.79. What is the difference between the highest and the lowest Gross enrolment ratio (%) of Tertiary schools?
Provide a short and direct response. 30.31. 